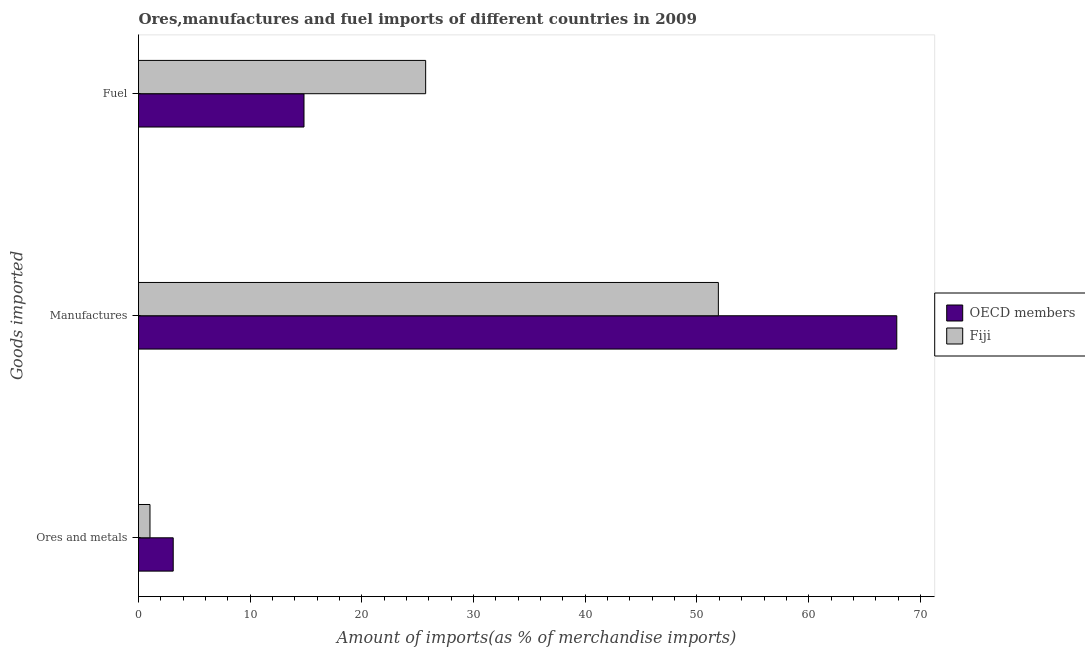Are the number of bars per tick equal to the number of legend labels?
Your answer should be compact. Yes. How many bars are there on the 1st tick from the top?
Your response must be concise. 2. What is the label of the 1st group of bars from the top?
Provide a short and direct response. Fuel. What is the percentage of manufactures imports in Fiji?
Offer a terse response. 51.91. Across all countries, what is the maximum percentage of manufactures imports?
Give a very brief answer. 67.89. Across all countries, what is the minimum percentage of fuel imports?
Provide a succinct answer. 14.82. In which country was the percentage of fuel imports maximum?
Provide a short and direct response. Fiji. What is the total percentage of ores and metals imports in the graph?
Give a very brief answer. 4.14. What is the difference between the percentage of fuel imports in OECD members and that in Fiji?
Offer a very short reply. -10.89. What is the difference between the percentage of fuel imports in OECD members and the percentage of ores and metals imports in Fiji?
Keep it short and to the point. 13.79. What is the average percentage of fuel imports per country?
Your answer should be compact. 20.26. What is the difference between the percentage of ores and metals imports and percentage of fuel imports in OECD members?
Offer a very short reply. -11.71. In how many countries, is the percentage of ores and metals imports greater than 24 %?
Offer a terse response. 0. What is the ratio of the percentage of ores and metals imports in Fiji to that in OECD members?
Offer a terse response. 0.33. Is the difference between the percentage of fuel imports in OECD members and Fiji greater than the difference between the percentage of manufactures imports in OECD members and Fiji?
Give a very brief answer. No. What is the difference between the highest and the second highest percentage of ores and metals imports?
Offer a very short reply. 2.08. What is the difference between the highest and the lowest percentage of manufactures imports?
Ensure brevity in your answer.  15.97. Is it the case that in every country, the sum of the percentage of ores and metals imports and percentage of manufactures imports is greater than the percentage of fuel imports?
Make the answer very short. Yes. How many countries are there in the graph?
Your answer should be compact. 2. What is the difference between two consecutive major ticks on the X-axis?
Make the answer very short. 10. Are the values on the major ticks of X-axis written in scientific E-notation?
Your answer should be compact. No. Does the graph contain any zero values?
Your answer should be very brief. No. Where does the legend appear in the graph?
Give a very brief answer. Center right. How many legend labels are there?
Your answer should be compact. 2. What is the title of the graph?
Offer a very short reply. Ores,manufactures and fuel imports of different countries in 2009. Does "Swaziland" appear as one of the legend labels in the graph?
Your response must be concise. No. What is the label or title of the X-axis?
Give a very brief answer. Amount of imports(as % of merchandise imports). What is the label or title of the Y-axis?
Offer a terse response. Goods imported. What is the Amount of imports(as % of merchandise imports) in OECD members in Ores and metals?
Provide a short and direct response. 3.11. What is the Amount of imports(as % of merchandise imports) in Fiji in Ores and metals?
Offer a very short reply. 1.03. What is the Amount of imports(as % of merchandise imports) in OECD members in Manufactures?
Ensure brevity in your answer.  67.89. What is the Amount of imports(as % of merchandise imports) of Fiji in Manufactures?
Make the answer very short. 51.91. What is the Amount of imports(as % of merchandise imports) of OECD members in Fuel?
Your answer should be compact. 14.82. What is the Amount of imports(as % of merchandise imports) in Fiji in Fuel?
Your response must be concise. 25.71. Across all Goods imported, what is the maximum Amount of imports(as % of merchandise imports) in OECD members?
Offer a very short reply. 67.89. Across all Goods imported, what is the maximum Amount of imports(as % of merchandise imports) in Fiji?
Your answer should be compact. 51.91. Across all Goods imported, what is the minimum Amount of imports(as % of merchandise imports) of OECD members?
Offer a very short reply. 3.11. Across all Goods imported, what is the minimum Amount of imports(as % of merchandise imports) in Fiji?
Provide a short and direct response. 1.03. What is the total Amount of imports(as % of merchandise imports) in OECD members in the graph?
Your answer should be compact. 85.81. What is the total Amount of imports(as % of merchandise imports) in Fiji in the graph?
Offer a terse response. 78.65. What is the difference between the Amount of imports(as % of merchandise imports) of OECD members in Ores and metals and that in Manufactures?
Your answer should be compact. -64.78. What is the difference between the Amount of imports(as % of merchandise imports) in Fiji in Ores and metals and that in Manufactures?
Make the answer very short. -50.89. What is the difference between the Amount of imports(as % of merchandise imports) in OECD members in Ores and metals and that in Fuel?
Your response must be concise. -11.71. What is the difference between the Amount of imports(as % of merchandise imports) in Fiji in Ores and metals and that in Fuel?
Offer a terse response. -24.68. What is the difference between the Amount of imports(as % of merchandise imports) of OECD members in Manufactures and that in Fuel?
Provide a short and direct response. 53.07. What is the difference between the Amount of imports(as % of merchandise imports) of Fiji in Manufactures and that in Fuel?
Make the answer very short. 26.21. What is the difference between the Amount of imports(as % of merchandise imports) in OECD members in Ores and metals and the Amount of imports(as % of merchandise imports) in Fiji in Manufactures?
Ensure brevity in your answer.  -48.81. What is the difference between the Amount of imports(as % of merchandise imports) in OECD members in Ores and metals and the Amount of imports(as % of merchandise imports) in Fiji in Fuel?
Provide a succinct answer. -22.6. What is the difference between the Amount of imports(as % of merchandise imports) in OECD members in Manufactures and the Amount of imports(as % of merchandise imports) in Fiji in Fuel?
Your answer should be very brief. 42.18. What is the average Amount of imports(as % of merchandise imports) in OECD members per Goods imported?
Offer a very short reply. 28.6. What is the average Amount of imports(as % of merchandise imports) of Fiji per Goods imported?
Keep it short and to the point. 26.22. What is the difference between the Amount of imports(as % of merchandise imports) in OECD members and Amount of imports(as % of merchandise imports) in Fiji in Ores and metals?
Make the answer very short. 2.08. What is the difference between the Amount of imports(as % of merchandise imports) of OECD members and Amount of imports(as % of merchandise imports) of Fiji in Manufactures?
Provide a succinct answer. 15.97. What is the difference between the Amount of imports(as % of merchandise imports) of OECD members and Amount of imports(as % of merchandise imports) of Fiji in Fuel?
Provide a short and direct response. -10.89. What is the ratio of the Amount of imports(as % of merchandise imports) of OECD members in Ores and metals to that in Manufactures?
Keep it short and to the point. 0.05. What is the ratio of the Amount of imports(as % of merchandise imports) of Fiji in Ores and metals to that in Manufactures?
Provide a succinct answer. 0.02. What is the ratio of the Amount of imports(as % of merchandise imports) of OECD members in Ores and metals to that in Fuel?
Keep it short and to the point. 0.21. What is the ratio of the Amount of imports(as % of merchandise imports) in OECD members in Manufactures to that in Fuel?
Keep it short and to the point. 4.58. What is the ratio of the Amount of imports(as % of merchandise imports) in Fiji in Manufactures to that in Fuel?
Your response must be concise. 2.02. What is the difference between the highest and the second highest Amount of imports(as % of merchandise imports) of OECD members?
Keep it short and to the point. 53.07. What is the difference between the highest and the second highest Amount of imports(as % of merchandise imports) of Fiji?
Your answer should be compact. 26.21. What is the difference between the highest and the lowest Amount of imports(as % of merchandise imports) in OECD members?
Ensure brevity in your answer.  64.78. What is the difference between the highest and the lowest Amount of imports(as % of merchandise imports) of Fiji?
Ensure brevity in your answer.  50.89. 